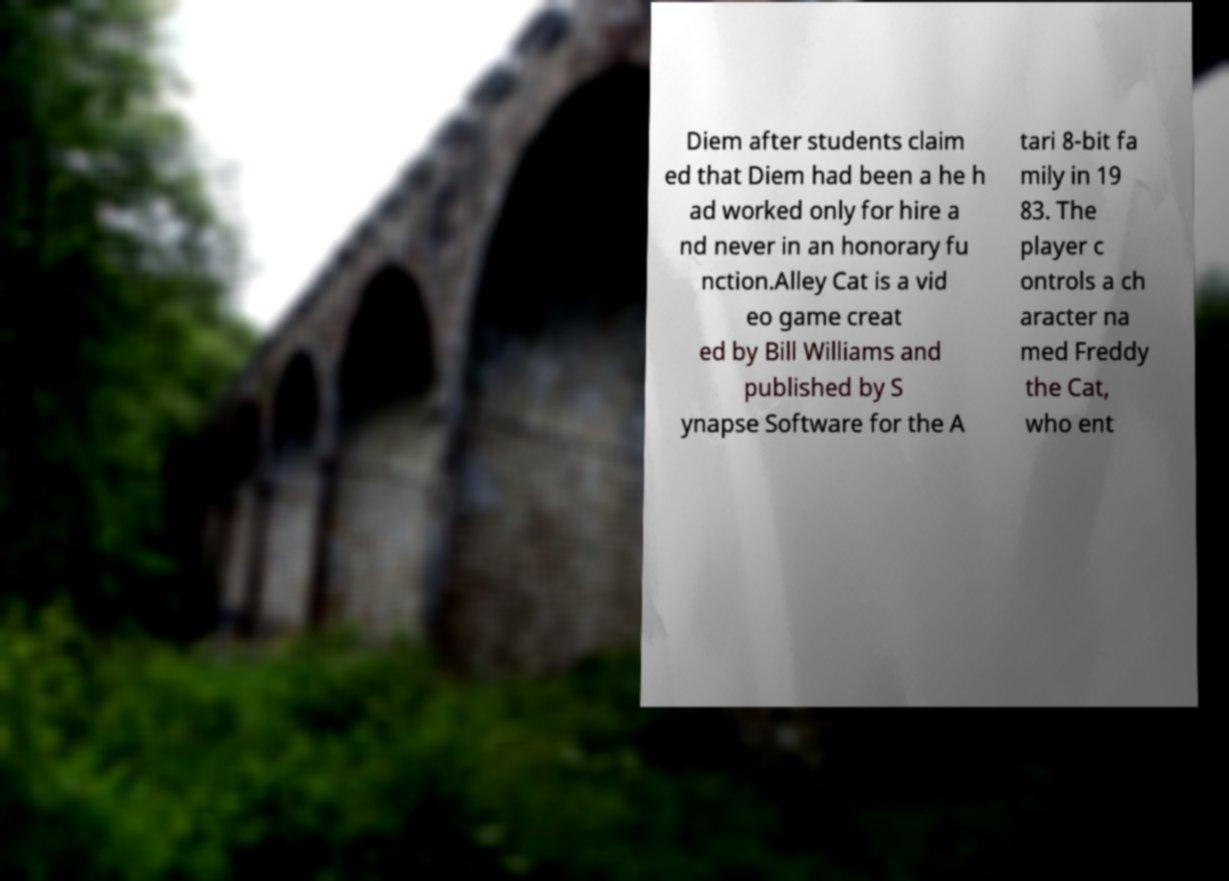Could you extract and type out the text from this image? Diem after students claim ed that Diem had been a he h ad worked only for hire a nd never in an honorary fu nction.Alley Cat is a vid eo game creat ed by Bill Williams and published by S ynapse Software for the A tari 8-bit fa mily in 19 83. The player c ontrols a ch aracter na med Freddy the Cat, who ent 